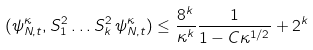Convert formula to latex. <formula><loc_0><loc_0><loc_500><loc_500>( \psi ^ { \kappa } _ { N , t } , S _ { 1 } ^ { 2 } \dots S _ { k } ^ { 2 } \, \psi ^ { \kappa } _ { N , t } ) \leq \frac { 8 ^ { k } } { \kappa ^ { k } } \frac { 1 } { 1 - C \kappa ^ { 1 / 2 } } + 2 ^ { k }</formula> 